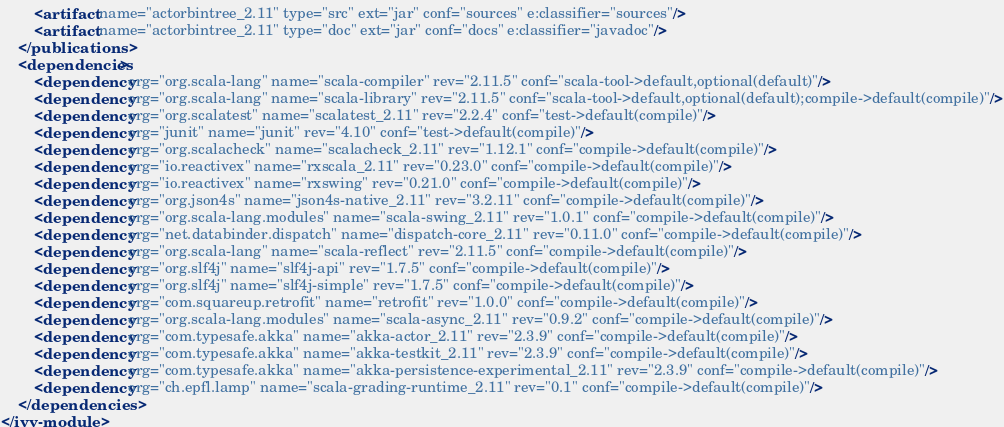<code> <loc_0><loc_0><loc_500><loc_500><_XML_>		<artifact name="actorbintree_2.11" type="src" ext="jar" conf="sources" e:classifier="sources"/>
		<artifact name="actorbintree_2.11" type="doc" ext="jar" conf="docs" e:classifier="javadoc"/>
	</publications>
	<dependencies>
		<dependency org="org.scala-lang" name="scala-compiler" rev="2.11.5" conf="scala-tool->default,optional(default)"/>
		<dependency org="org.scala-lang" name="scala-library" rev="2.11.5" conf="scala-tool->default,optional(default);compile->default(compile)"/>
		<dependency org="org.scalatest" name="scalatest_2.11" rev="2.2.4" conf="test->default(compile)"/>
		<dependency org="junit" name="junit" rev="4.10" conf="test->default(compile)"/>
		<dependency org="org.scalacheck" name="scalacheck_2.11" rev="1.12.1" conf="compile->default(compile)"/>
		<dependency org="io.reactivex" name="rxscala_2.11" rev="0.23.0" conf="compile->default(compile)"/>
		<dependency org="io.reactivex" name="rxswing" rev="0.21.0" conf="compile->default(compile)"/>
		<dependency org="org.json4s" name="json4s-native_2.11" rev="3.2.11" conf="compile->default(compile)"/>
		<dependency org="org.scala-lang.modules" name="scala-swing_2.11" rev="1.0.1" conf="compile->default(compile)"/>
		<dependency org="net.databinder.dispatch" name="dispatch-core_2.11" rev="0.11.0" conf="compile->default(compile)"/>
		<dependency org="org.scala-lang" name="scala-reflect" rev="2.11.5" conf="compile->default(compile)"/>
		<dependency org="org.slf4j" name="slf4j-api" rev="1.7.5" conf="compile->default(compile)"/>
		<dependency org="org.slf4j" name="slf4j-simple" rev="1.7.5" conf="compile->default(compile)"/>
		<dependency org="com.squareup.retrofit" name="retrofit" rev="1.0.0" conf="compile->default(compile)"/>
		<dependency org="org.scala-lang.modules" name="scala-async_2.11" rev="0.9.2" conf="compile->default(compile)"/>
		<dependency org="com.typesafe.akka" name="akka-actor_2.11" rev="2.3.9" conf="compile->default(compile)"/>
		<dependency org="com.typesafe.akka" name="akka-testkit_2.11" rev="2.3.9" conf="compile->default(compile)"/>
		<dependency org="com.typesafe.akka" name="akka-persistence-experimental_2.11" rev="2.3.9" conf="compile->default(compile)"/>
		<dependency org="ch.epfl.lamp" name="scala-grading-runtime_2.11" rev="0.1" conf="compile->default(compile)"/>
	</dependencies>
</ivy-module>
</code> 